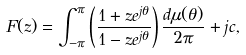<formula> <loc_0><loc_0><loc_500><loc_500>F ( z ) = \int _ { - \pi } ^ { \pi } \left ( \frac { 1 + z e ^ { j \theta } } { 1 - z e ^ { j \theta } } \right ) \frac { d \mu ( \theta ) } { 2 \pi } + j c ,</formula> 